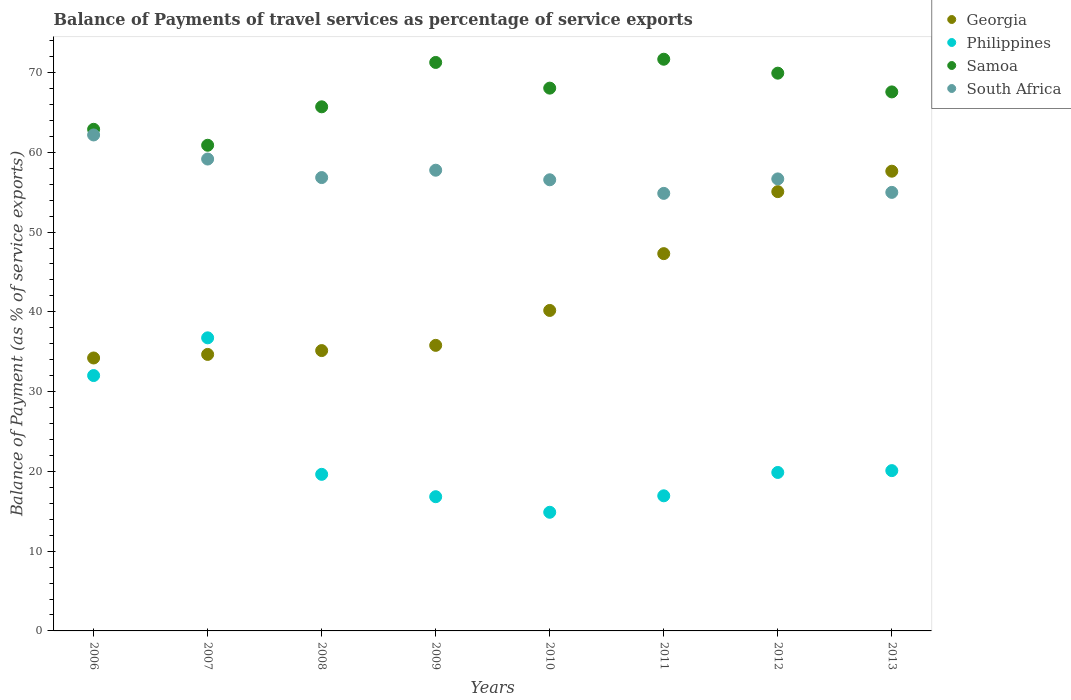How many different coloured dotlines are there?
Your answer should be compact. 4. Is the number of dotlines equal to the number of legend labels?
Make the answer very short. Yes. What is the balance of payments of travel services in Samoa in 2008?
Provide a succinct answer. 65.71. Across all years, what is the maximum balance of payments of travel services in South Africa?
Offer a terse response. 62.18. Across all years, what is the minimum balance of payments of travel services in Philippines?
Make the answer very short. 14.87. In which year was the balance of payments of travel services in Samoa maximum?
Keep it short and to the point. 2011. In which year was the balance of payments of travel services in Philippines minimum?
Make the answer very short. 2010. What is the total balance of payments of travel services in South Africa in the graph?
Your response must be concise. 458.98. What is the difference between the balance of payments of travel services in Samoa in 2006 and that in 2007?
Provide a succinct answer. 2. What is the difference between the balance of payments of travel services in Philippines in 2009 and the balance of payments of travel services in South Africa in 2012?
Offer a very short reply. -39.84. What is the average balance of payments of travel services in Philippines per year?
Ensure brevity in your answer.  22.12. In the year 2011, what is the difference between the balance of payments of travel services in Georgia and balance of payments of travel services in South Africa?
Offer a very short reply. -7.55. In how many years, is the balance of payments of travel services in Philippines greater than 12 %?
Provide a succinct answer. 8. What is the ratio of the balance of payments of travel services in South Africa in 2008 to that in 2010?
Your answer should be compact. 1. Is the difference between the balance of payments of travel services in Georgia in 2007 and 2011 greater than the difference between the balance of payments of travel services in South Africa in 2007 and 2011?
Your response must be concise. No. What is the difference between the highest and the second highest balance of payments of travel services in Georgia?
Your answer should be compact. 2.56. What is the difference between the highest and the lowest balance of payments of travel services in Samoa?
Your answer should be compact. 10.78. Is it the case that in every year, the sum of the balance of payments of travel services in Georgia and balance of payments of travel services in Samoa  is greater than the sum of balance of payments of travel services in Philippines and balance of payments of travel services in South Africa?
Offer a very short reply. No. Is the balance of payments of travel services in Philippines strictly greater than the balance of payments of travel services in Georgia over the years?
Make the answer very short. No. Where does the legend appear in the graph?
Ensure brevity in your answer.  Top right. How are the legend labels stacked?
Provide a short and direct response. Vertical. What is the title of the graph?
Your answer should be very brief. Balance of Payments of travel services as percentage of service exports. What is the label or title of the Y-axis?
Make the answer very short. Balance of Payment (as % of service exports). What is the Balance of Payment (as % of service exports) in Georgia in 2006?
Give a very brief answer. 34.22. What is the Balance of Payment (as % of service exports) of Philippines in 2006?
Offer a terse response. 32.02. What is the Balance of Payment (as % of service exports) of Samoa in 2006?
Provide a short and direct response. 62.88. What is the Balance of Payment (as % of service exports) of South Africa in 2006?
Offer a very short reply. 62.18. What is the Balance of Payment (as % of service exports) in Georgia in 2007?
Offer a very short reply. 34.66. What is the Balance of Payment (as % of service exports) of Philippines in 2007?
Your answer should be very brief. 36.74. What is the Balance of Payment (as % of service exports) of Samoa in 2007?
Offer a terse response. 60.89. What is the Balance of Payment (as % of service exports) of South Africa in 2007?
Your answer should be very brief. 59.16. What is the Balance of Payment (as % of service exports) in Georgia in 2008?
Provide a succinct answer. 35.15. What is the Balance of Payment (as % of service exports) in Philippines in 2008?
Provide a short and direct response. 19.63. What is the Balance of Payment (as % of service exports) of Samoa in 2008?
Ensure brevity in your answer.  65.71. What is the Balance of Payment (as % of service exports) of South Africa in 2008?
Your response must be concise. 56.83. What is the Balance of Payment (as % of service exports) of Georgia in 2009?
Ensure brevity in your answer.  35.8. What is the Balance of Payment (as % of service exports) of Philippines in 2009?
Provide a succinct answer. 16.83. What is the Balance of Payment (as % of service exports) of Samoa in 2009?
Make the answer very short. 71.27. What is the Balance of Payment (as % of service exports) of South Africa in 2009?
Make the answer very short. 57.76. What is the Balance of Payment (as % of service exports) in Georgia in 2010?
Your response must be concise. 40.18. What is the Balance of Payment (as % of service exports) of Philippines in 2010?
Give a very brief answer. 14.87. What is the Balance of Payment (as % of service exports) in Samoa in 2010?
Make the answer very short. 68.05. What is the Balance of Payment (as % of service exports) of South Africa in 2010?
Ensure brevity in your answer.  56.56. What is the Balance of Payment (as % of service exports) in Georgia in 2011?
Offer a terse response. 47.3. What is the Balance of Payment (as % of service exports) in Philippines in 2011?
Offer a very short reply. 16.94. What is the Balance of Payment (as % of service exports) of Samoa in 2011?
Provide a succinct answer. 71.67. What is the Balance of Payment (as % of service exports) of South Africa in 2011?
Provide a succinct answer. 54.85. What is the Balance of Payment (as % of service exports) of Georgia in 2012?
Your answer should be very brief. 55.07. What is the Balance of Payment (as % of service exports) in Philippines in 2012?
Your answer should be compact. 19.87. What is the Balance of Payment (as % of service exports) in Samoa in 2012?
Make the answer very short. 69.92. What is the Balance of Payment (as % of service exports) of South Africa in 2012?
Your response must be concise. 56.67. What is the Balance of Payment (as % of service exports) in Georgia in 2013?
Offer a very short reply. 57.63. What is the Balance of Payment (as % of service exports) of Philippines in 2013?
Provide a succinct answer. 20.1. What is the Balance of Payment (as % of service exports) in Samoa in 2013?
Make the answer very short. 67.57. What is the Balance of Payment (as % of service exports) of South Africa in 2013?
Provide a succinct answer. 54.98. Across all years, what is the maximum Balance of Payment (as % of service exports) of Georgia?
Your answer should be very brief. 57.63. Across all years, what is the maximum Balance of Payment (as % of service exports) of Philippines?
Keep it short and to the point. 36.74. Across all years, what is the maximum Balance of Payment (as % of service exports) in Samoa?
Provide a succinct answer. 71.67. Across all years, what is the maximum Balance of Payment (as % of service exports) of South Africa?
Your answer should be very brief. 62.18. Across all years, what is the minimum Balance of Payment (as % of service exports) in Georgia?
Ensure brevity in your answer.  34.22. Across all years, what is the minimum Balance of Payment (as % of service exports) in Philippines?
Offer a terse response. 14.87. Across all years, what is the minimum Balance of Payment (as % of service exports) of Samoa?
Keep it short and to the point. 60.89. Across all years, what is the minimum Balance of Payment (as % of service exports) of South Africa?
Offer a very short reply. 54.85. What is the total Balance of Payment (as % of service exports) of Georgia in the graph?
Offer a terse response. 340.01. What is the total Balance of Payment (as % of service exports) in Philippines in the graph?
Ensure brevity in your answer.  176.99. What is the total Balance of Payment (as % of service exports) in Samoa in the graph?
Provide a short and direct response. 537.96. What is the total Balance of Payment (as % of service exports) of South Africa in the graph?
Your answer should be very brief. 458.98. What is the difference between the Balance of Payment (as % of service exports) of Georgia in 2006 and that in 2007?
Provide a short and direct response. -0.45. What is the difference between the Balance of Payment (as % of service exports) in Philippines in 2006 and that in 2007?
Provide a short and direct response. -4.73. What is the difference between the Balance of Payment (as % of service exports) in Samoa in 2006 and that in 2007?
Provide a succinct answer. 2. What is the difference between the Balance of Payment (as % of service exports) of South Africa in 2006 and that in 2007?
Offer a very short reply. 3.02. What is the difference between the Balance of Payment (as % of service exports) of Georgia in 2006 and that in 2008?
Offer a very short reply. -0.93. What is the difference between the Balance of Payment (as % of service exports) in Philippines in 2006 and that in 2008?
Provide a succinct answer. 12.39. What is the difference between the Balance of Payment (as % of service exports) in Samoa in 2006 and that in 2008?
Your answer should be very brief. -2.82. What is the difference between the Balance of Payment (as % of service exports) of South Africa in 2006 and that in 2008?
Your response must be concise. 5.34. What is the difference between the Balance of Payment (as % of service exports) of Georgia in 2006 and that in 2009?
Offer a very short reply. -1.58. What is the difference between the Balance of Payment (as % of service exports) of Philippines in 2006 and that in 2009?
Your answer should be compact. 15.19. What is the difference between the Balance of Payment (as % of service exports) in Samoa in 2006 and that in 2009?
Provide a succinct answer. -8.38. What is the difference between the Balance of Payment (as % of service exports) in South Africa in 2006 and that in 2009?
Provide a short and direct response. 4.42. What is the difference between the Balance of Payment (as % of service exports) of Georgia in 2006 and that in 2010?
Keep it short and to the point. -5.96. What is the difference between the Balance of Payment (as % of service exports) of Philippines in 2006 and that in 2010?
Your answer should be compact. 17.14. What is the difference between the Balance of Payment (as % of service exports) of Samoa in 2006 and that in 2010?
Make the answer very short. -5.16. What is the difference between the Balance of Payment (as % of service exports) of South Africa in 2006 and that in 2010?
Make the answer very short. 5.62. What is the difference between the Balance of Payment (as % of service exports) in Georgia in 2006 and that in 2011?
Make the answer very short. -13.08. What is the difference between the Balance of Payment (as % of service exports) in Philippines in 2006 and that in 2011?
Your response must be concise. 15.08. What is the difference between the Balance of Payment (as % of service exports) in Samoa in 2006 and that in 2011?
Your answer should be compact. -8.79. What is the difference between the Balance of Payment (as % of service exports) of South Africa in 2006 and that in 2011?
Give a very brief answer. 7.32. What is the difference between the Balance of Payment (as % of service exports) in Georgia in 2006 and that in 2012?
Your response must be concise. -20.85. What is the difference between the Balance of Payment (as % of service exports) in Philippines in 2006 and that in 2012?
Your answer should be compact. 12.15. What is the difference between the Balance of Payment (as % of service exports) in Samoa in 2006 and that in 2012?
Keep it short and to the point. -7.04. What is the difference between the Balance of Payment (as % of service exports) of South Africa in 2006 and that in 2012?
Offer a very short reply. 5.51. What is the difference between the Balance of Payment (as % of service exports) in Georgia in 2006 and that in 2013?
Ensure brevity in your answer.  -23.42. What is the difference between the Balance of Payment (as % of service exports) in Philippines in 2006 and that in 2013?
Offer a very short reply. 11.92. What is the difference between the Balance of Payment (as % of service exports) of Samoa in 2006 and that in 2013?
Make the answer very short. -4.69. What is the difference between the Balance of Payment (as % of service exports) of South Africa in 2006 and that in 2013?
Your answer should be compact. 7.2. What is the difference between the Balance of Payment (as % of service exports) of Georgia in 2007 and that in 2008?
Your answer should be compact. -0.48. What is the difference between the Balance of Payment (as % of service exports) of Philippines in 2007 and that in 2008?
Your answer should be compact. 17.11. What is the difference between the Balance of Payment (as % of service exports) in Samoa in 2007 and that in 2008?
Offer a terse response. -4.82. What is the difference between the Balance of Payment (as % of service exports) in South Africa in 2007 and that in 2008?
Provide a succinct answer. 2.32. What is the difference between the Balance of Payment (as % of service exports) of Georgia in 2007 and that in 2009?
Offer a very short reply. -1.14. What is the difference between the Balance of Payment (as % of service exports) of Philippines in 2007 and that in 2009?
Provide a succinct answer. 19.92. What is the difference between the Balance of Payment (as % of service exports) of Samoa in 2007 and that in 2009?
Your response must be concise. -10.38. What is the difference between the Balance of Payment (as % of service exports) in South Africa in 2007 and that in 2009?
Ensure brevity in your answer.  1.4. What is the difference between the Balance of Payment (as % of service exports) of Georgia in 2007 and that in 2010?
Offer a very short reply. -5.51. What is the difference between the Balance of Payment (as % of service exports) of Philippines in 2007 and that in 2010?
Keep it short and to the point. 21.87. What is the difference between the Balance of Payment (as % of service exports) of Samoa in 2007 and that in 2010?
Give a very brief answer. -7.16. What is the difference between the Balance of Payment (as % of service exports) in South Africa in 2007 and that in 2010?
Your response must be concise. 2.6. What is the difference between the Balance of Payment (as % of service exports) of Georgia in 2007 and that in 2011?
Your answer should be compact. -12.63. What is the difference between the Balance of Payment (as % of service exports) of Philippines in 2007 and that in 2011?
Offer a terse response. 19.81. What is the difference between the Balance of Payment (as % of service exports) in Samoa in 2007 and that in 2011?
Your response must be concise. -10.79. What is the difference between the Balance of Payment (as % of service exports) in South Africa in 2007 and that in 2011?
Ensure brevity in your answer.  4.3. What is the difference between the Balance of Payment (as % of service exports) of Georgia in 2007 and that in 2012?
Offer a very short reply. -20.41. What is the difference between the Balance of Payment (as % of service exports) in Philippines in 2007 and that in 2012?
Keep it short and to the point. 16.88. What is the difference between the Balance of Payment (as % of service exports) in Samoa in 2007 and that in 2012?
Your answer should be compact. -9.04. What is the difference between the Balance of Payment (as % of service exports) of South Africa in 2007 and that in 2012?
Offer a terse response. 2.49. What is the difference between the Balance of Payment (as % of service exports) in Georgia in 2007 and that in 2013?
Give a very brief answer. -22.97. What is the difference between the Balance of Payment (as % of service exports) of Philippines in 2007 and that in 2013?
Offer a very short reply. 16.65. What is the difference between the Balance of Payment (as % of service exports) of Samoa in 2007 and that in 2013?
Offer a very short reply. -6.69. What is the difference between the Balance of Payment (as % of service exports) in South Africa in 2007 and that in 2013?
Offer a very short reply. 4.18. What is the difference between the Balance of Payment (as % of service exports) of Georgia in 2008 and that in 2009?
Your response must be concise. -0.65. What is the difference between the Balance of Payment (as % of service exports) in Philippines in 2008 and that in 2009?
Make the answer very short. 2.8. What is the difference between the Balance of Payment (as % of service exports) of Samoa in 2008 and that in 2009?
Make the answer very short. -5.56. What is the difference between the Balance of Payment (as % of service exports) of South Africa in 2008 and that in 2009?
Ensure brevity in your answer.  -0.92. What is the difference between the Balance of Payment (as % of service exports) of Georgia in 2008 and that in 2010?
Provide a succinct answer. -5.03. What is the difference between the Balance of Payment (as % of service exports) in Philippines in 2008 and that in 2010?
Provide a succinct answer. 4.75. What is the difference between the Balance of Payment (as % of service exports) of Samoa in 2008 and that in 2010?
Your answer should be compact. -2.34. What is the difference between the Balance of Payment (as % of service exports) in South Africa in 2008 and that in 2010?
Make the answer very short. 0.28. What is the difference between the Balance of Payment (as % of service exports) of Georgia in 2008 and that in 2011?
Offer a very short reply. -12.15. What is the difference between the Balance of Payment (as % of service exports) in Philippines in 2008 and that in 2011?
Make the answer very short. 2.69. What is the difference between the Balance of Payment (as % of service exports) in Samoa in 2008 and that in 2011?
Your response must be concise. -5.97. What is the difference between the Balance of Payment (as % of service exports) of South Africa in 2008 and that in 2011?
Ensure brevity in your answer.  1.98. What is the difference between the Balance of Payment (as % of service exports) in Georgia in 2008 and that in 2012?
Provide a short and direct response. -19.93. What is the difference between the Balance of Payment (as % of service exports) of Philippines in 2008 and that in 2012?
Ensure brevity in your answer.  -0.24. What is the difference between the Balance of Payment (as % of service exports) in Samoa in 2008 and that in 2012?
Your answer should be compact. -4.22. What is the difference between the Balance of Payment (as % of service exports) in South Africa in 2008 and that in 2012?
Provide a short and direct response. 0.17. What is the difference between the Balance of Payment (as % of service exports) in Georgia in 2008 and that in 2013?
Provide a succinct answer. -22.49. What is the difference between the Balance of Payment (as % of service exports) in Philippines in 2008 and that in 2013?
Your answer should be compact. -0.47. What is the difference between the Balance of Payment (as % of service exports) of Samoa in 2008 and that in 2013?
Keep it short and to the point. -1.87. What is the difference between the Balance of Payment (as % of service exports) in South Africa in 2008 and that in 2013?
Your response must be concise. 1.86. What is the difference between the Balance of Payment (as % of service exports) of Georgia in 2009 and that in 2010?
Your answer should be compact. -4.38. What is the difference between the Balance of Payment (as % of service exports) in Philippines in 2009 and that in 2010?
Keep it short and to the point. 1.95. What is the difference between the Balance of Payment (as % of service exports) of Samoa in 2009 and that in 2010?
Give a very brief answer. 3.22. What is the difference between the Balance of Payment (as % of service exports) of South Africa in 2009 and that in 2010?
Give a very brief answer. 1.2. What is the difference between the Balance of Payment (as % of service exports) of Georgia in 2009 and that in 2011?
Your response must be concise. -11.5. What is the difference between the Balance of Payment (as % of service exports) of Philippines in 2009 and that in 2011?
Ensure brevity in your answer.  -0.11. What is the difference between the Balance of Payment (as % of service exports) of Samoa in 2009 and that in 2011?
Provide a succinct answer. -0.4. What is the difference between the Balance of Payment (as % of service exports) of South Africa in 2009 and that in 2011?
Offer a very short reply. 2.9. What is the difference between the Balance of Payment (as % of service exports) in Georgia in 2009 and that in 2012?
Offer a very short reply. -19.27. What is the difference between the Balance of Payment (as % of service exports) in Philippines in 2009 and that in 2012?
Make the answer very short. -3.04. What is the difference between the Balance of Payment (as % of service exports) of Samoa in 2009 and that in 2012?
Your answer should be very brief. 1.34. What is the difference between the Balance of Payment (as % of service exports) of South Africa in 2009 and that in 2012?
Provide a short and direct response. 1.09. What is the difference between the Balance of Payment (as % of service exports) in Georgia in 2009 and that in 2013?
Provide a succinct answer. -21.83. What is the difference between the Balance of Payment (as % of service exports) in Philippines in 2009 and that in 2013?
Provide a short and direct response. -3.27. What is the difference between the Balance of Payment (as % of service exports) in Samoa in 2009 and that in 2013?
Your response must be concise. 3.69. What is the difference between the Balance of Payment (as % of service exports) of South Africa in 2009 and that in 2013?
Offer a very short reply. 2.78. What is the difference between the Balance of Payment (as % of service exports) of Georgia in 2010 and that in 2011?
Provide a succinct answer. -7.12. What is the difference between the Balance of Payment (as % of service exports) in Philippines in 2010 and that in 2011?
Provide a short and direct response. -2.06. What is the difference between the Balance of Payment (as % of service exports) in Samoa in 2010 and that in 2011?
Your answer should be compact. -3.62. What is the difference between the Balance of Payment (as % of service exports) of South Africa in 2010 and that in 2011?
Give a very brief answer. 1.7. What is the difference between the Balance of Payment (as % of service exports) of Georgia in 2010 and that in 2012?
Your answer should be compact. -14.89. What is the difference between the Balance of Payment (as % of service exports) of Philippines in 2010 and that in 2012?
Offer a very short reply. -4.99. What is the difference between the Balance of Payment (as % of service exports) of Samoa in 2010 and that in 2012?
Your answer should be compact. -1.88. What is the difference between the Balance of Payment (as % of service exports) in South Africa in 2010 and that in 2012?
Provide a succinct answer. -0.11. What is the difference between the Balance of Payment (as % of service exports) of Georgia in 2010 and that in 2013?
Your response must be concise. -17.46. What is the difference between the Balance of Payment (as % of service exports) of Philippines in 2010 and that in 2013?
Give a very brief answer. -5.22. What is the difference between the Balance of Payment (as % of service exports) in Samoa in 2010 and that in 2013?
Make the answer very short. 0.47. What is the difference between the Balance of Payment (as % of service exports) of South Africa in 2010 and that in 2013?
Provide a short and direct response. 1.58. What is the difference between the Balance of Payment (as % of service exports) in Georgia in 2011 and that in 2012?
Keep it short and to the point. -7.77. What is the difference between the Balance of Payment (as % of service exports) in Philippines in 2011 and that in 2012?
Give a very brief answer. -2.93. What is the difference between the Balance of Payment (as % of service exports) of Samoa in 2011 and that in 2012?
Offer a terse response. 1.75. What is the difference between the Balance of Payment (as % of service exports) in South Africa in 2011 and that in 2012?
Provide a short and direct response. -1.81. What is the difference between the Balance of Payment (as % of service exports) in Georgia in 2011 and that in 2013?
Provide a short and direct response. -10.34. What is the difference between the Balance of Payment (as % of service exports) of Philippines in 2011 and that in 2013?
Your response must be concise. -3.16. What is the difference between the Balance of Payment (as % of service exports) of Samoa in 2011 and that in 2013?
Provide a short and direct response. 4.1. What is the difference between the Balance of Payment (as % of service exports) of South Africa in 2011 and that in 2013?
Your answer should be compact. -0.12. What is the difference between the Balance of Payment (as % of service exports) in Georgia in 2012 and that in 2013?
Offer a very short reply. -2.56. What is the difference between the Balance of Payment (as % of service exports) of Philippines in 2012 and that in 2013?
Your answer should be compact. -0.23. What is the difference between the Balance of Payment (as % of service exports) of Samoa in 2012 and that in 2013?
Ensure brevity in your answer.  2.35. What is the difference between the Balance of Payment (as % of service exports) in South Africa in 2012 and that in 2013?
Offer a very short reply. 1.69. What is the difference between the Balance of Payment (as % of service exports) in Georgia in 2006 and the Balance of Payment (as % of service exports) in Philippines in 2007?
Your answer should be compact. -2.53. What is the difference between the Balance of Payment (as % of service exports) of Georgia in 2006 and the Balance of Payment (as % of service exports) of Samoa in 2007?
Your answer should be very brief. -26.67. What is the difference between the Balance of Payment (as % of service exports) of Georgia in 2006 and the Balance of Payment (as % of service exports) of South Africa in 2007?
Offer a terse response. -24.94. What is the difference between the Balance of Payment (as % of service exports) of Philippines in 2006 and the Balance of Payment (as % of service exports) of Samoa in 2007?
Ensure brevity in your answer.  -28.87. What is the difference between the Balance of Payment (as % of service exports) of Philippines in 2006 and the Balance of Payment (as % of service exports) of South Africa in 2007?
Offer a very short reply. -27.14. What is the difference between the Balance of Payment (as % of service exports) in Samoa in 2006 and the Balance of Payment (as % of service exports) in South Africa in 2007?
Provide a succinct answer. 3.73. What is the difference between the Balance of Payment (as % of service exports) of Georgia in 2006 and the Balance of Payment (as % of service exports) of Philippines in 2008?
Keep it short and to the point. 14.59. What is the difference between the Balance of Payment (as % of service exports) in Georgia in 2006 and the Balance of Payment (as % of service exports) in Samoa in 2008?
Make the answer very short. -31.49. What is the difference between the Balance of Payment (as % of service exports) in Georgia in 2006 and the Balance of Payment (as % of service exports) in South Africa in 2008?
Your answer should be very brief. -22.62. What is the difference between the Balance of Payment (as % of service exports) of Philippines in 2006 and the Balance of Payment (as % of service exports) of Samoa in 2008?
Your response must be concise. -33.69. What is the difference between the Balance of Payment (as % of service exports) in Philippines in 2006 and the Balance of Payment (as % of service exports) in South Africa in 2008?
Give a very brief answer. -24.82. What is the difference between the Balance of Payment (as % of service exports) of Samoa in 2006 and the Balance of Payment (as % of service exports) of South Africa in 2008?
Give a very brief answer. 6.05. What is the difference between the Balance of Payment (as % of service exports) of Georgia in 2006 and the Balance of Payment (as % of service exports) of Philippines in 2009?
Keep it short and to the point. 17.39. What is the difference between the Balance of Payment (as % of service exports) in Georgia in 2006 and the Balance of Payment (as % of service exports) in Samoa in 2009?
Give a very brief answer. -37.05. What is the difference between the Balance of Payment (as % of service exports) in Georgia in 2006 and the Balance of Payment (as % of service exports) in South Africa in 2009?
Keep it short and to the point. -23.54. What is the difference between the Balance of Payment (as % of service exports) in Philippines in 2006 and the Balance of Payment (as % of service exports) in Samoa in 2009?
Keep it short and to the point. -39.25. What is the difference between the Balance of Payment (as % of service exports) in Philippines in 2006 and the Balance of Payment (as % of service exports) in South Africa in 2009?
Your answer should be very brief. -25.74. What is the difference between the Balance of Payment (as % of service exports) in Samoa in 2006 and the Balance of Payment (as % of service exports) in South Africa in 2009?
Your answer should be very brief. 5.13. What is the difference between the Balance of Payment (as % of service exports) in Georgia in 2006 and the Balance of Payment (as % of service exports) in Philippines in 2010?
Keep it short and to the point. 19.34. What is the difference between the Balance of Payment (as % of service exports) in Georgia in 2006 and the Balance of Payment (as % of service exports) in Samoa in 2010?
Offer a terse response. -33.83. What is the difference between the Balance of Payment (as % of service exports) in Georgia in 2006 and the Balance of Payment (as % of service exports) in South Africa in 2010?
Give a very brief answer. -22.34. What is the difference between the Balance of Payment (as % of service exports) of Philippines in 2006 and the Balance of Payment (as % of service exports) of Samoa in 2010?
Give a very brief answer. -36.03. What is the difference between the Balance of Payment (as % of service exports) in Philippines in 2006 and the Balance of Payment (as % of service exports) in South Africa in 2010?
Provide a short and direct response. -24.54. What is the difference between the Balance of Payment (as % of service exports) of Samoa in 2006 and the Balance of Payment (as % of service exports) of South Africa in 2010?
Keep it short and to the point. 6.33. What is the difference between the Balance of Payment (as % of service exports) in Georgia in 2006 and the Balance of Payment (as % of service exports) in Philippines in 2011?
Make the answer very short. 17.28. What is the difference between the Balance of Payment (as % of service exports) in Georgia in 2006 and the Balance of Payment (as % of service exports) in Samoa in 2011?
Offer a very short reply. -37.45. What is the difference between the Balance of Payment (as % of service exports) of Georgia in 2006 and the Balance of Payment (as % of service exports) of South Africa in 2011?
Provide a succinct answer. -20.64. What is the difference between the Balance of Payment (as % of service exports) of Philippines in 2006 and the Balance of Payment (as % of service exports) of Samoa in 2011?
Keep it short and to the point. -39.66. What is the difference between the Balance of Payment (as % of service exports) of Philippines in 2006 and the Balance of Payment (as % of service exports) of South Africa in 2011?
Ensure brevity in your answer.  -22.84. What is the difference between the Balance of Payment (as % of service exports) of Samoa in 2006 and the Balance of Payment (as % of service exports) of South Africa in 2011?
Your response must be concise. 8.03. What is the difference between the Balance of Payment (as % of service exports) of Georgia in 2006 and the Balance of Payment (as % of service exports) of Philippines in 2012?
Your answer should be very brief. 14.35. What is the difference between the Balance of Payment (as % of service exports) in Georgia in 2006 and the Balance of Payment (as % of service exports) in Samoa in 2012?
Keep it short and to the point. -35.71. What is the difference between the Balance of Payment (as % of service exports) of Georgia in 2006 and the Balance of Payment (as % of service exports) of South Africa in 2012?
Ensure brevity in your answer.  -22.45. What is the difference between the Balance of Payment (as % of service exports) of Philippines in 2006 and the Balance of Payment (as % of service exports) of Samoa in 2012?
Give a very brief answer. -37.91. What is the difference between the Balance of Payment (as % of service exports) of Philippines in 2006 and the Balance of Payment (as % of service exports) of South Africa in 2012?
Your answer should be very brief. -24.65. What is the difference between the Balance of Payment (as % of service exports) of Samoa in 2006 and the Balance of Payment (as % of service exports) of South Africa in 2012?
Make the answer very short. 6.22. What is the difference between the Balance of Payment (as % of service exports) in Georgia in 2006 and the Balance of Payment (as % of service exports) in Philippines in 2013?
Provide a short and direct response. 14.12. What is the difference between the Balance of Payment (as % of service exports) of Georgia in 2006 and the Balance of Payment (as % of service exports) of Samoa in 2013?
Make the answer very short. -33.36. What is the difference between the Balance of Payment (as % of service exports) in Georgia in 2006 and the Balance of Payment (as % of service exports) in South Africa in 2013?
Your answer should be compact. -20.76. What is the difference between the Balance of Payment (as % of service exports) in Philippines in 2006 and the Balance of Payment (as % of service exports) in Samoa in 2013?
Make the answer very short. -35.56. What is the difference between the Balance of Payment (as % of service exports) in Philippines in 2006 and the Balance of Payment (as % of service exports) in South Africa in 2013?
Provide a succinct answer. -22.96. What is the difference between the Balance of Payment (as % of service exports) in Samoa in 2006 and the Balance of Payment (as % of service exports) in South Africa in 2013?
Provide a short and direct response. 7.91. What is the difference between the Balance of Payment (as % of service exports) of Georgia in 2007 and the Balance of Payment (as % of service exports) of Philippines in 2008?
Provide a short and direct response. 15.03. What is the difference between the Balance of Payment (as % of service exports) in Georgia in 2007 and the Balance of Payment (as % of service exports) in Samoa in 2008?
Your answer should be compact. -31.04. What is the difference between the Balance of Payment (as % of service exports) of Georgia in 2007 and the Balance of Payment (as % of service exports) of South Africa in 2008?
Ensure brevity in your answer.  -22.17. What is the difference between the Balance of Payment (as % of service exports) in Philippines in 2007 and the Balance of Payment (as % of service exports) in Samoa in 2008?
Give a very brief answer. -28.96. What is the difference between the Balance of Payment (as % of service exports) of Philippines in 2007 and the Balance of Payment (as % of service exports) of South Africa in 2008?
Keep it short and to the point. -20.09. What is the difference between the Balance of Payment (as % of service exports) in Samoa in 2007 and the Balance of Payment (as % of service exports) in South Africa in 2008?
Provide a succinct answer. 4.05. What is the difference between the Balance of Payment (as % of service exports) in Georgia in 2007 and the Balance of Payment (as % of service exports) in Philippines in 2009?
Your response must be concise. 17.84. What is the difference between the Balance of Payment (as % of service exports) of Georgia in 2007 and the Balance of Payment (as % of service exports) of Samoa in 2009?
Your answer should be very brief. -36.6. What is the difference between the Balance of Payment (as % of service exports) in Georgia in 2007 and the Balance of Payment (as % of service exports) in South Africa in 2009?
Your response must be concise. -23.09. What is the difference between the Balance of Payment (as % of service exports) in Philippines in 2007 and the Balance of Payment (as % of service exports) in Samoa in 2009?
Your answer should be very brief. -34.52. What is the difference between the Balance of Payment (as % of service exports) in Philippines in 2007 and the Balance of Payment (as % of service exports) in South Africa in 2009?
Keep it short and to the point. -21.01. What is the difference between the Balance of Payment (as % of service exports) of Samoa in 2007 and the Balance of Payment (as % of service exports) of South Africa in 2009?
Your answer should be very brief. 3.13. What is the difference between the Balance of Payment (as % of service exports) in Georgia in 2007 and the Balance of Payment (as % of service exports) in Philippines in 2010?
Offer a terse response. 19.79. What is the difference between the Balance of Payment (as % of service exports) in Georgia in 2007 and the Balance of Payment (as % of service exports) in Samoa in 2010?
Offer a very short reply. -33.38. What is the difference between the Balance of Payment (as % of service exports) of Georgia in 2007 and the Balance of Payment (as % of service exports) of South Africa in 2010?
Your response must be concise. -21.89. What is the difference between the Balance of Payment (as % of service exports) in Philippines in 2007 and the Balance of Payment (as % of service exports) in Samoa in 2010?
Give a very brief answer. -31.3. What is the difference between the Balance of Payment (as % of service exports) of Philippines in 2007 and the Balance of Payment (as % of service exports) of South Africa in 2010?
Give a very brief answer. -19.81. What is the difference between the Balance of Payment (as % of service exports) of Samoa in 2007 and the Balance of Payment (as % of service exports) of South Africa in 2010?
Provide a succinct answer. 4.33. What is the difference between the Balance of Payment (as % of service exports) of Georgia in 2007 and the Balance of Payment (as % of service exports) of Philippines in 2011?
Offer a very short reply. 17.73. What is the difference between the Balance of Payment (as % of service exports) in Georgia in 2007 and the Balance of Payment (as % of service exports) in Samoa in 2011?
Your answer should be compact. -37.01. What is the difference between the Balance of Payment (as % of service exports) of Georgia in 2007 and the Balance of Payment (as % of service exports) of South Africa in 2011?
Provide a succinct answer. -20.19. What is the difference between the Balance of Payment (as % of service exports) in Philippines in 2007 and the Balance of Payment (as % of service exports) in Samoa in 2011?
Provide a succinct answer. -34.93. What is the difference between the Balance of Payment (as % of service exports) in Philippines in 2007 and the Balance of Payment (as % of service exports) in South Africa in 2011?
Offer a very short reply. -18.11. What is the difference between the Balance of Payment (as % of service exports) of Samoa in 2007 and the Balance of Payment (as % of service exports) of South Africa in 2011?
Keep it short and to the point. 6.03. What is the difference between the Balance of Payment (as % of service exports) in Georgia in 2007 and the Balance of Payment (as % of service exports) in Philippines in 2012?
Provide a succinct answer. 14.8. What is the difference between the Balance of Payment (as % of service exports) in Georgia in 2007 and the Balance of Payment (as % of service exports) in Samoa in 2012?
Keep it short and to the point. -35.26. What is the difference between the Balance of Payment (as % of service exports) in Georgia in 2007 and the Balance of Payment (as % of service exports) in South Africa in 2012?
Your response must be concise. -22. What is the difference between the Balance of Payment (as % of service exports) of Philippines in 2007 and the Balance of Payment (as % of service exports) of Samoa in 2012?
Keep it short and to the point. -33.18. What is the difference between the Balance of Payment (as % of service exports) of Philippines in 2007 and the Balance of Payment (as % of service exports) of South Africa in 2012?
Give a very brief answer. -19.92. What is the difference between the Balance of Payment (as % of service exports) of Samoa in 2007 and the Balance of Payment (as % of service exports) of South Africa in 2012?
Offer a terse response. 4.22. What is the difference between the Balance of Payment (as % of service exports) of Georgia in 2007 and the Balance of Payment (as % of service exports) of Philippines in 2013?
Provide a succinct answer. 14.57. What is the difference between the Balance of Payment (as % of service exports) in Georgia in 2007 and the Balance of Payment (as % of service exports) in Samoa in 2013?
Make the answer very short. -32.91. What is the difference between the Balance of Payment (as % of service exports) in Georgia in 2007 and the Balance of Payment (as % of service exports) in South Africa in 2013?
Provide a succinct answer. -20.31. What is the difference between the Balance of Payment (as % of service exports) of Philippines in 2007 and the Balance of Payment (as % of service exports) of Samoa in 2013?
Make the answer very short. -30.83. What is the difference between the Balance of Payment (as % of service exports) of Philippines in 2007 and the Balance of Payment (as % of service exports) of South Africa in 2013?
Make the answer very short. -18.23. What is the difference between the Balance of Payment (as % of service exports) of Samoa in 2007 and the Balance of Payment (as % of service exports) of South Africa in 2013?
Your answer should be compact. 5.91. What is the difference between the Balance of Payment (as % of service exports) of Georgia in 2008 and the Balance of Payment (as % of service exports) of Philippines in 2009?
Your answer should be compact. 18.32. What is the difference between the Balance of Payment (as % of service exports) of Georgia in 2008 and the Balance of Payment (as % of service exports) of Samoa in 2009?
Provide a succinct answer. -36.12. What is the difference between the Balance of Payment (as % of service exports) of Georgia in 2008 and the Balance of Payment (as % of service exports) of South Africa in 2009?
Keep it short and to the point. -22.61. What is the difference between the Balance of Payment (as % of service exports) of Philippines in 2008 and the Balance of Payment (as % of service exports) of Samoa in 2009?
Keep it short and to the point. -51.64. What is the difference between the Balance of Payment (as % of service exports) of Philippines in 2008 and the Balance of Payment (as % of service exports) of South Africa in 2009?
Provide a succinct answer. -38.13. What is the difference between the Balance of Payment (as % of service exports) of Samoa in 2008 and the Balance of Payment (as % of service exports) of South Africa in 2009?
Provide a succinct answer. 7.95. What is the difference between the Balance of Payment (as % of service exports) of Georgia in 2008 and the Balance of Payment (as % of service exports) of Philippines in 2010?
Offer a very short reply. 20.27. What is the difference between the Balance of Payment (as % of service exports) of Georgia in 2008 and the Balance of Payment (as % of service exports) of Samoa in 2010?
Offer a terse response. -32.9. What is the difference between the Balance of Payment (as % of service exports) in Georgia in 2008 and the Balance of Payment (as % of service exports) in South Africa in 2010?
Your response must be concise. -21.41. What is the difference between the Balance of Payment (as % of service exports) in Philippines in 2008 and the Balance of Payment (as % of service exports) in Samoa in 2010?
Your answer should be compact. -48.42. What is the difference between the Balance of Payment (as % of service exports) in Philippines in 2008 and the Balance of Payment (as % of service exports) in South Africa in 2010?
Your answer should be very brief. -36.93. What is the difference between the Balance of Payment (as % of service exports) of Samoa in 2008 and the Balance of Payment (as % of service exports) of South Africa in 2010?
Your answer should be very brief. 9.15. What is the difference between the Balance of Payment (as % of service exports) in Georgia in 2008 and the Balance of Payment (as % of service exports) in Philippines in 2011?
Make the answer very short. 18.21. What is the difference between the Balance of Payment (as % of service exports) of Georgia in 2008 and the Balance of Payment (as % of service exports) of Samoa in 2011?
Keep it short and to the point. -36.53. What is the difference between the Balance of Payment (as % of service exports) in Georgia in 2008 and the Balance of Payment (as % of service exports) in South Africa in 2011?
Keep it short and to the point. -19.71. What is the difference between the Balance of Payment (as % of service exports) in Philippines in 2008 and the Balance of Payment (as % of service exports) in Samoa in 2011?
Make the answer very short. -52.04. What is the difference between the Balance of Payment (as % of service exports) of Philippines in 2008 and the Balance of Payment (as % of service exports) of South Africa in 2011?
Your response must be concise. -35.22. What is the difference between the Balance of Payment (as % of service exports) in Samoa in 2008 and the Balance of Payment (as % of service exports) in South Africa in 2011?
Provide a succinct answer. 10.85. What is the difference between the Balance of Payment (as % of service exports) in Georgia in 2008 and the Balance of Payment (as % of service exports) in Philippines in 2012?
Your answer should be compact. 15.28. What is the difference between the Balance of Payment (as % of service exports) in Georgia in 2008 and the Balance of Payment (as % of service exports) in Samoa in 2012?
Your answer should be compact. -34.78. What is the difference between the Balance of Payment (as % of service exports) of Georgia in 2008 and the Balance of Payment (as % of service exports) of South Africa in 2012?
Your answer should be compact. -21.52. What is the difference between the Balance of Payment (as % of service exports) of Philippines in 2008 and the Balance of Payment (as % of service exports) of Samoa in 2012?
Make the answer very short. -50.29. What is the difference between the Balance of Payment (as % of service exports) in Philippines in 2008 and the Balance of Payment (as % of service exports) in South Africa in 2012?
Keep it short and to the point. -37.04. What is the difference between the Balance of Payment (as % of service exports) in Samoa in 2008 and the Balance of Payment (as % of service exports) in South Africa in 2012?
Offer a terse response. 9.04. What is the difference between the Balance of Payment (as % of service exports) in Georgia in 2008 and the Balance of Payment (as % of service exports) in Philippines in 2013?
Provide a short and direct response. 15.05. What is the difference between the Balance of Payment (as % of service exports) in Georgia in 2008 and the Balance of Payment (as % of service exports) in Samoa in 2013?
Your answer should be very brief. -32.43. What is the difference between the Balance of Payment (as % of service exports) in Georgia in 2008 and the Balance of Payment (as % of service exports) in South Africa in 2013?
Your response must be concise. -19.83. What is the difference between the Balance of Payment (as % of service exports) of Philippines in 2008 and the Balance of Payment (as % of service exports) of Samoa in 2013?
Ensure brevity in your answer.  -47.94. What is the difference between the Balance of Payment (as % of service exports) of Philippines in 2008 and the Balance of Payment (as % of service exports) of South Africa in 2013?
Provide a short and direct response. -35.35. What is the difference between the Balance of Payment (as % of service exports) of Samoa in 2008 and the Balance of Payment (as % of service exports) of South Africa in 2013?
Your answer should be very brief. 10.73. What is the difference between the Balance of Payment (as % of service exports) in Georgia in 2009 and the Balance of Payment (as % of service exports) in Philippines in 2010?
Provide a succinct answer. 20.92. What is the difference between the Balance of Payment (as % of service exports) of Georgia in 2009 and the Balance of Payment (as % of service exports) of Samoa in 2010?
Your answer should be compact. -32.25. What is the difference between the Balance of Payment (as % of service exports) in Georgia in 2009 and the Balance of Payment (as % of service exports) in South Africa in 2010?
Offer a terse response. -20.76. What is the difference between the Balance of Payment (as % of service exports) of Philippines in 2009 and the Balance of Payment (as % of service exports) of Samoa in 2010?
Offer a very short reply. -51.22. What is the difference between the Balance of Payment (as % of service exports) of Philippines in 2009 and the Balance of Payment (as % of service exports) of South Africa in 2010?
Ensure brevity in your answer.  -39.73. What is the difference between the Balance of Payment (as % of service exports) in Samoa in 2009 and the Balance of Payment (as % of service exports) in South Africa in 2010?
Keep it short and to the point. 14.71. What is the difference between the Balance of Payment (as % of service exports) in Georgia in 2009 and the Balance of Payment (as % of service exports) in Philippines in 2011?
Your response must be concise. 18.86. What is the difference between the Balance of Payment (as % of service exports) in Georgia in 2009 and the Balance of Payment (as % of service exports) in Samoa in 2011?
Your answer should be compact. -35.87. What is the difference between the Balance of Payment (as % of service exports) of Georgia in 2009 and the Balance of Payment (as % of service exports) of South Africa in 2011?
Your response must be concise. -19.05. What is the difference between the Balance of Payment (as % of service exports) of Philippines in 2009 and the Balance of Payment (as % of service exports) of Samoa in 2011?
Your response must be concise. -54.84. What is the difference between the Balance of Payment (as % of service exports) of Philippines in 2009 and the Balance of Payment (as % of service exports) of South Africa in 2011?
Offer a very short reply. -38.03. What is the difference between the Balance of Payment (as % of service exports) of Samoa in 2009 and the Balance of Payment (as % of service exports) of South Africa in 2011?
Offer a very short reply. 16.42. What is the difference between the Balance of Payment (as % of service exports) of Georgia in 2009 and the Balance of Payment (as % of service exports) of Philippines in 2012?
Give a very brief answer. 15.93. What is the difference between the Balance of Payment (as % of service exports) of Georgia in 2009 and the Balance of Payment (as % of service exports) of Samoa in 2012?
Provide a short and direct response. -34.12. What is the difference between the Balance of Payment (as % of service exports) in Georgia in 2009 and the Balance of Payment (as % of service exports) in South Africa in 2012?
Provide a succinct answer. -20.87. What is the difference between the Balance of Payment (as % of service exports) of Philippines in 2009 and the Balance of Payment (as % of service exports) of Samoa in 2012?
Your answer should be very brief. -53.1. What is the difference between the Balance of Payment (as % of service exports) in Philippines in 2009 and the Balance of Payment (as % of service exports) in South Africa in 2012?
Provide a short and direct response. -39.84. What is the difference between the Balance of Payment (as % of service exports) of Samoa in 2009 and the Balance of Payment (as % of service exports) of South Africa in 2012?
Provide a short and direct response. 14.6. What is the difference between the Balance of Payment (as % of service exports) in Georgia in 2009 and the Balance of Payment (as % of service exports) in Philippines in 2013?
Offer a very short reply. 15.7. What is the difference between the Balance of Payment (as % of service exports) of Georgia in 2009 and the Balance of Payment (as % of service exports) of Samoa in 2013?
Give a very brief answer. -31.77. What is the difference between the Balance of Payment (as % of service exports) of Georgia in 2009 and the Balance of Payment (as % of service exports) of South Africa in 2013?
Your answer should be compact. -19.18. What is the difference between the Balance of Payment (as % of service exports) of Philippines in 2009 and the Balance of Payment (as % of service exports) of Samoa in 2013?
Offer a terse response. -50.75. What is the difference between the Balance of Payment (as % of service exports) in Philippines in 2009 and the Balance of Payment (as % of service exports) in South Africa in 2013?
Your response must be concise. -38.15. What is the difference between the Balance of Payment (as % of service exports) in Samoa in 2009 and the Balance of Payment (as % of service exports) in South Africa in 2013?
Make the answer very short. 16.29. What is the difference between the Balance of Payment (as % of service exports) of Georgia in 2010 and the Balance of Payment (as % of service exports) of Philippines in 2011?
Provide a succinct answer. 23.24. What is the difference between the Balance of Payment (as % of service exports) of Georgia in 2010 and the Balance of Payment (as % of service exports) of Samoa in 2011?
Your response must be concise. -31.49. What is the difference between the Balance of Payment (as % of service exports) of Georgia in 2010 and the Balance of Payment (as % of service exports) of South Africa in 2011?
Offer a terse response. -14.68. What is the difference between the Balance of Payment (as % of service exports) in Philippines in 2010 and the Balance of Payment (as % of service exports) in Samoa in 2011?
Make the answer very short. -56.8. What is the difference between the Balance of Payment (as % of service exports) in Philippines in 2010 and the Balance of Payment (as % of service exports) in South Africa in 2011?
Your answer should be very brief. -39.98. What is the difference between the Balance of Payment (as % of service exports) in Samoa in 2010 and the Balance of Payment (as % of service exports) in South Africa in 2011?
Provide a succinct answer. 13.19. What is the difference between the Balance of Payment (as % of service exports) of Georgia in 2010 and the Balance of Payment (as % of service exports) of Philippines in 2012?
Your response must be concise. 20.31. What is the difference between the Balance of Payment (as % of service exports) in Georgia in 2010 and the Balance of Payment (as % of service exports) in Samoa in 2012?
Ensure brevity in your answer.  -29.75. What is the difference between the Balance of Payment (as % of service exports) of Georgia in 2010 and the Balance of Payment (as % of service exports) of South Africa in 2012?
Keep it short and to the point. -16.49. What is the difference between the Balance of Payment (as % of service exports) in Philippines in 2010 and the Balance of Payment (as % of service exports) in Samoa in 2012?
Your answer should be very brief. -55.05. What is the difference between the Balance of Payment (as % of service exports) of Philippines in 2010 and the Balance of Payment (as % of service exports) of South Africa in 2012?
Keep it short and to the point. -41.79. What is the difference between the Balance of Payment (as % of service exports) of Samoa in 2010 and the Balance of Payment (as % of service exports) of South Africa in 2012?
Keep it short and to the point. 11.38. What is the difference between the Balance of Payment (as % of service exports) of Georgia in 2010 and the Balance of Payment (as % of service exports) of Philippines in 2013?
Your answer should be compact. 20.08. What is the difference between the Balance of Payment (as % of service exports) in Georgia in 2010 and the Balance of Payment (as % of service exports) in Samoa in 2013?
Offer a terse response. -27.4. What is the difference between the Balance of Payment (as % of service exports) in Georgia in 2010 and the Balance of Payment (as % of service exports) in South Africa in 2013?
Your answer should be very brief. -14.8. What is the difference between the Balance of Payment (as % of service exports) in Philippines in 2010 and the Balance of Payment (as % of service exports) in Samoa in 2013?
Give a very brief answer. -52.7. What is the difference between the Balance of Payment (as % of service exports) in Philippines in 2010 and the Balance of Payment (as % of service exports) in South Africa in 2013?
Provide a succinct answer. -40.1. What is the difference between the Balance of Payment (as % of service exports) of Samoa in 2010 and the Balance of Payment (as % of service exports) of South Africa in 2013?
Your response must be concise. 13.07. What is the difference between the Balance of Payment (as % of service exports) of Georgia in 2011 and the Balance of Payment (as % of service exports) of Philippines in 2012?
Your response must be concise. 27.43. What is the difference between the Balance of Payment (as % of service exports) in Georgia in 2011 and the Balance of Payment (as % of service exports) in Samoa in 2012?
Provide a succinct answer. -22.63. What is the difference between the Balance of Payment (as % of service exports) of Georgia in 2011 and the Balance of Payment (as % of service exports) of South Africa in 2012?
Offer a terse response. -9.37. What is the difference between the Balance of Payment (as % of service exports) of Philippines in 2011 and the Balance of Payment (as % of service exports) of Samoa in 2012?
Give a very brief answer. -52.99. What is the difference between the Balance of Payment (as % of service exports) in Philippines in 2011 and the Balance of Payment (as % of service exports) in South Africa in 2012?
Give a very brief answer. -39.73. What is the difference between the Balance of Payment (as % of service exports) of Samoa in 2011 and the Balance of Payment (as % of service exports) of South Africa in 2012?
Offer a terse response. 15. What is the difference between the Balance of Payment (as % of service exports) of Georgia in 2011 and the Balance of Payment (as % of service exports) of Philippines in 2013?
Keep it short and to the point. 27.2. What is the difference between the Balance of Payment (as % of service exports) of Georgia in 2011 and the Balance of Payment (as % of service exports) of Samoa in 2013?
Ensure brevity in your answer.  -20.28. What is the difference between the Balance of Payment (as % of service exports) of Georgia in 2011 and the Balance of Payment (as % of service exports) of South Africa in 2013?
Give a very brief answer. -7.68. What is the difference between the Balance of Payment (as % of service exports) in Philippines in 2011 and the Balance of Payment (as % of service exports) in Samoa in 2013?
Keep it short and to the point. -50.64. What is the difference between the Balance of Payment (as % of service exports) in Philippines in 2011 and the Balance of Payment (as % of service exports) in South Africa in 2013?
Your response must be concise. -38.04. What is the difference between the Balance of Payment (as % of service exports) in Samoa in 2011 and the Balance of Payment (as % of service exports) in South Africa in 2013?
Provide a short and direct response. 16.69. What is the difference between the Balance of Payment (as % of service exports) in Georgia in 2012 and the Balance of Payment (as % of service exports) in Philippines in 2013?
Give a very brief answer. 34.97. What is the difference between the Balance of Payment (as % of service exports) of Georgia in 2012 and the Balance of Payment (as % of service exports) of Samoa in 2013?
Offer a terse response. -12.5. What is the difference between the Balance of Payment (as % of service exports) in Georgia in 2012 and the Balance of Payment (as % of service exports) in South Africa in 2013?
Provide a short and direct response. 0.09. What is the difference between the Balance of Payment (as % of service exports) of Philippines in 2012 and the Balance of Payment (as % of service exports) of Samoa in 2013?
Make the answer very short. -47.71. What is the difference between the Balance of Payment (as % of service exports) of Philippines in 2012 and the Balance of Payment (as % of service exports) of South Africa in 2013?
Provide a short and direct response. -35.11. What is the difference between the Balance of Payment (as % of service exports) in Samoa in 2012 and the Balance of Payment (as % of service exports) in South Africa in 2013?
Ensure brevity in your answer.  14.95. What is the average Balance of Payment (as % of service exports) in Georgia per year?
Provide a short and direct response. 42.5. What is the average Balance of Payment (as % of service exports) of Philippines per year?
Provide a succinct answer. 22.12. What is the average Balance of Payment (as % of service exports) in Samoa per year?
Your response must be concise. 67.24. What is the average Balance of Payment (as % of service exports) of South Africa per year?
Offer a very short reply. 57.37. In the year 2006, what is the difference between the Balance of Payment (as % of service exports) of Georgia and Balance of Payment (as % of service exports) of Philippines?
Keep it short and to the point. 2.2. In the year 2006, what is the difference between the Balance of Payment (as % of service exports) of Georgia and Balance of Payment (as % of service exports) of Samoa?
Provide a short and direct response. -28.67. In the year 2006, what is the difference between the Balance of Payment (as % of service exports) in Georgia and Balance of Payment (as % of service exports) in South Africa?
Keep it short and to the point. -27.96. In the year 2006, what is the difference between the Balance of Payment (as % of service exports) of Philippines and Balance of Payment (as % of service exports) of Samoa?
Give a very brief answer. -30.87. In the year 2006, what is the difference between the Balance of Payment (as % of service exports) of Philippines and Balance of Payment (as % of service exports) of South Africa?
Provide a succinct answer. -30.16. In the year 2006, what is the difference between the Balance of Payment (as % of service exports) of Samoa and Balance of Payment (as % of service exports) of South Africa?
Keep it short and to the point. 0.71. In the year 2007, what is the difference between the Balance of Payment (as % of service exports) of Georgia and Balance of Payment (as % of service exports) of Philippines?
Your answer should be compact. -2.08. In the year 2007, what is the difference between the Balance of Payment (as % of service exports) in Georgia and Balance of Payment (as % of service exports) in Samoa?
Provide a succinct answer. -26.22. In the year 2007, what is the difference between the Balance of Payment (as % of service exports) of Georgia and Balance of Payment (as % of service exports) of South Africa?
Your response must be concise. -24.49. In the year 2007, what is the difference between the Balance of Payment (as % of service exports) in Philippines and Balance of Payment (as % of service exports) in Samoa?
Offer a terse response. -24.14. In the year 2007, what is the difference between the Balance of Payment (as % of service exports) of Philippines and Balance of Payment (as % of service exports) of South Africa?
Your answer should be very brief. -22.41. In the year 2007, what is the difference between the Balance of Payment (as % of service exports) in Samoa and Balance of Payment (as % of service exports) in South Africa?
Keep it short and to the point. 1.73. In the year 2008, what is the difference between the Balance of Payment (as % of service exports) of Georgia and Balance of Payment (as % of service exports) of Philippines?
Keep it short and to the point. 15.52. In the year 2008, what is the difference between the Balance of Payment (as % of service exports) of Georgia and Balance of Payment (as % of service exports) of Samoa?
Make the answer very short. -30.56. In the year 2008, what is the difference between the Balance of Payment (as % of service exports) in Georgia and Balance of Payment (as % of service exports) in South Africa?
Provide a short and direct response. -21.69. In the year 2008, what is the difference between the Balance of Payment (as % of service exports) in Philippines and Balance of Payment (as % of service exports) in Samoa?
Offer a terse response. -46.08. In the year 2008, what is the difference between the Balance of Payment (as % of service exports) of Philippines and Balance of Payment (as % of service exports) of South Africa?
Your response must be concise. -37.21. In the year 2008, what is the difference between the Balance of Payment (as % of service exports) in Samoa and Balance of Payment (as % of service exports) in South Africa?
Your response must be concise. 8.87. In the year 2009, what is the difference between the Balance of Payment (as % of service exports) in Georgia and Balance of Payment (as % of service exports) in Philippines?
Your response must be concise. 18.97. In the year 2009, what is the difference between the Balance of Payment (as % of service exports) in Georgia and Balance of Payment (as % of service exports) in Samoa?
Keep it short and to the point. -35.47. In the year 2009, what is the difference between the Balance of Payment (as % of service exports) in Georgia and Balance of Payment (as % of service exports) in South Africa?
Your answer should be very brief. -21.96. In the year 2009, what is the difference between the Balance of Payment (as % of service exports) in Philippines and Balance of Payment (as % of service exports) in Samoa?
Provide a succinct answer. -54.44. In the year 2009, what is the difference between the Balance of Payment (as % of service exports) in Philippines and Balance of Payment (as % of service exports) in South Africa?
Provide a short and direct response. -40.93. In the year 2009, what is the difference between the Balance of Payment (as % of service exports) of Samoa and Balance of Payment (as % of service exports) of South Africa?
Provide a succinct answer. 13.51. In the year 2010, what is the difference between the Balance of Payment (as % of service exports) in Georgia and Balance of Payment (as % of service exports) in Philippines?
Keep it short and to the point. 25.3. In the year 2010, what is the difference between the Balance of Payment (as % of service exports) of Georgia and Balance of Payment (as % of service exports) of Samoa?
Offer a very short reply. -27.87. In the year 2010, what is the difference between the Balance of Payment (as % of service exports) of Georgia and Balance of Payment (as % of service exports) of South Africa?
Ensure brevity in your answer.  -16.38. In the year 2010, what is the difference between the Balance of Payment (as % of service exports) in Philippines and Balance of Payment (as % of service exports) in Samoa?
Your response must be concise. -53.17. In the year 2010, what is the difference between the Balance of Payment (as % of service exports) of Philippines and Balance of Payment (as % of service exports) of South Africa?
Offer a terse response. -41.68. In the year 2010, what is the difference between the Balance of Payment (as % of service exports) of Samoa and Balance of Payment (as % of service exports) of South Africa?
Provide a short and direct response. 11.49. In the year 2011, what is the difference between the Balance of Payment (as % of service exports) of Georgia and Balance of Payment (as % of service exports) of Philippines?
Your response must be concise. 30.36. In the year 2011, what is the difference between the Balance of Payment (as % of service exports) of Georgia and Balance of Payment (as % of service exports) of Samoa?
Give a very brief answer. -24.37. In the year 2011, what is the difference between the Balance of Payment (as % of service exports) of Georgia and Balance of Payment (as % of service exports) of South Africa?
Offer a very short reply. -7.55. In the year 2011, what is the difference between the Balance of Payment (as % of service exports) of Philippines and Balance of Payment (as % of service exports) of Samoa?
Your answer should be compact. -54.73. In the year 2011, what is the difference between the Balance of Payment (as % of service exports) of Philippines and Balance of Payment (as % of service exports) of South Africa?
Make the answer very short. -37.91. In the year 2011, what is the difference between the Balance of Payment (as % of service exports) in Samoa and Balance of Payment (as % of service exports) in South Africa?
Your answer should be very brief. 16.82. In the year 2012, what is the difference between the Balance of Payment (as % of service exports) in Georgia and Balance of Payment (as % of service exports) in Philippines?
Your answer should be very brief. 35.2. In the year 2012, what is the difference between the Balance of Payment (as % of service exports) in Georgia and Balance of Payment (as % of service exports) in Samoa?
Offer a very short reply. -14.85. In the year 2012, what is the difference between the Balance of Payment (as % of service exports) of Georgia and Balance of Payment (as % of service exports) of South Africa?
Make the answer very short. -1.6. In the year 2012, what is the difference between the Balance of Payment (as % of service exports) in Philippines and Balance of Payment (as % of service exports) in Samoa?
Provide a succinct answer. -50.06. In the year 2012, what is the difference between the Balance of Payment (as % of service exports) in Philippines and Balance of Payment (as % of service exports) in South Africa?
Offer a very short reply. -36.8. In the year 2012, what is the difference between the Balance of Payment (as % of service exports) in Samoa and Balance of Payment (as % of service exports) in South Africa?
Offer a very short reply. 13.26. In the year 2013, what is the difference between the Balance of Payment (as % of service exports) of Georgia and Balance of Payment (as % of service exports) of Philippines?
Ensure brevity in your answer.  37.54. In the year 2013, what is the difference between the Balance of Payment (as % of service exports) in Georgia and Balance of Payment (as % of service exports) in Samoa?
Provide a short and direct response. -9.94. In the year 2013, what is the difference between the Balance of Payment (as % of service exports) in Georgia and Balance of Payment (as % of service exports) in South Africa?
Provide a succinct answer. 2.66. In the year 2013, what is the difference between the Balance of Payment (as % of service exports) of Philippines and Balance of Payment (as % of service exports) of Samoa?
Keep it short and to the point. -47.48. In the year 2013, what is the difference between the Balance of Payment (as % of service exports) in Philippines and Balance of Payment (as % of service exports) in South Africa?
Keep it short and to the point. -34.88. In the year 2013, what is the difference between the Balance of Payment (as % of service exports) of Samoa and Balance of Payment (as % of service exports) of South Africa?
Give a very brief answer. 12.6. What is the ratio of the Balance of Payment (as % of service exports) in Georgia in 2006 to that in 2007?
Keep it short and to the point. 0.99. What is the ratio of the Balance of Payment (as % of service exports) of Philippines in 2006 to that in 2007?
Give a very brief answer. 0.87. What is the ratio of the Balance of Payment (as % of service exports) in Samoa in 2006 to that in 2007?
Make the answer very short. 1.03. What is the ratio of the Balance of Payment (as % of service exports) in South Africa in 2006 to that in 2007?
Make the answer very short. 1.05. What is the ratio of the Balance of Payment (as % of service exports) in Georgia in 2006 to that in 2008?
Provide a short and direct response. 0.97. What is the ratio of the Balance of Payment (as % of service exports) of Philippines in 2006 to that in 2008?
Provide a succinct answer. 1.63. What is the ratio of the Balance of Payment (as % of service exports) of Samoa in 2006 to that in 2008?
Offer a very short reply. 0.96. What is the ratio of the Balance of Payment (as % of service exports) in South Africa in 2006 to that in 2008?
Your answer should be very brief. 1.09. What is the ratio of the Balance of Payment (as % of service exports) of Georgia in 2006 to that in 2009?
Make the answer very short. 0.96. What is the ratio of the Balance of Payment (as % of service exports) in Philippines in 2006 to that in 2009?
Provide a succinct answer. 1.9. What is the ratio of the Balance of Payment (as % of service exports) of Samoa in 2006 to that in 2009?
Offer a terse response. 0.88. What is the ratio of the Balance of Payment (as % of service exports) of South Africa in 2006 to that in 2009?
Your response must be concise. 1.08. What is the ratio of the Balance of Payment (as % of service exports) in Georgia in 2006 to that in 2010?
Your response must be concise. 0.85. What is the ratio of the Balance of Payment (as % of service exports) in Philippines in 2006 to that in 2010?
Make the answer very short. 2.15. What is the ratio of the Balance of Payment (as % of service exports) in Samoa in 2006 to that in 2010?
Make the answer very short. 0.92. What is the ratio of the Balance of Payment (as % of service exports) of South Africa in 2006 to that in 2010?
Make the answer very short. 1.1. What is the ratio of the Balance of Payment (as % of service exports) of Georgia in 2006 to that in 2011?
Provide a short and direct response. 0.72. What is the ratio of the Balance of Payment (as % of service exports) of Philippines in 2006 to that in 2011?
Give a very brief answer. 1.89. What is the ratio of the Balance of Payment (as % of service exports) in Samoa in 2006 to that in 2011?
Offer a terse response. 0.88. What is the ratio of the Balance of Payment (as % of service exports) in South Africa in 2006 to that in 2011?
Keep it short and to the point. 1.13. What is the ratio of the Balance of Payment (as % of service exports) in Georgia in 2006 to that in 2012?
Give a very brief answer. 0.62. What is the ratio of the Balance of Payment (as % of service exports) in Philippines in 2006 to that in 2012?
Keep it short and to the point. 1.61. What is the ratio of the Balance of Payment (as % of service exports) of Samoa in 2006 to that in 2012?
Provide a succinct answer. 0.9. What is the ratio of the Balance of Payment (as % of service exports) in South Africa in 2006 to that in 2012?
Your response must be concise. 1.1. What is the ratio of the Balance of Payment (as % of service exports) of Georgia in 2006 to that in 2013?
Provide a short and direct response. 0.59. What is the ratio of the Balance of Payment (as % of service exports) in Philippines in 2006 to that in 2013?
Keep it short and to the point. 1.59. What is the ratio of the Balance of Payment (as % of service exports) of Samoa in 2006 to that in 2013?
Give a very brief answer. 0.93. What is the ratio of the Balance of Payment (as % of service exports) of South Africa in 2006 to that in 2013?
Your response must be concise. 1.13. What is the ratio of the Balance of Payment (as % of service exports) of Georgia in 2007 to that in 2008?
Give a very brief answer. 0.99. What is the ratio of the Balance of Payment (as % of service exports) of Philippines in 2007 to that in 2008?
Offer a very short reply. 1.87. What is the ratio of the Balance of Payment (as % of service exports) in Samoa in 2007 to that in 2008?
Make the answer very short. 0.93. What is the ratio of the Balance of Payment (as % of service exports) of South Africa in 2007 to that in 2008?
Keep it short and to the point. 1.04. What is the ratio of the Balance of Payment (as % of service exports) in Georgia in 2007 to that in 2009?
Ensure brevity in your answer.  0.97. What is the ratio of the Balance of Payment (as % of service exports) of Philippines in 2007 to that in 2009?
Ensure brevity in your answer.  2.18. What is the ratio of the Balance of Payment (as % of service exports) in Samoa in 2007 to that in 2009?
Give a very brief answer. 0.85. What is the ratio of the Balance of Payment (as % of service exports) in South Africa in 2007 to that in 2009?
Your response must be concise. 1.02. What is the ratio of the Balance of Payment (as % of service exports) in Georgia in 2007 to that in 2010?
Offer a terse response. 0.86. What is the ratio of the Balance of Payment (as % of service exports) of Philippines in 2007 to that in 2010?
Offer a very short reply. 2.47. What is the ratio of the Balance of Payment (as % of service exports) in Samoa in 2007 to that in 2010?
Keep it short and to the point. 0.89. What is the ratio of the Balance of Payment (as % of service exports) of South Africa in 2007 to that in 2010?
Ensure brevity in your answer.  1.05. What is the ratio of the Balance of Payment (as % of service exports) of Georgia in 2007 to that in 2011?
Ensure brevity in your answer.  0.73. What is the ratio of the Balance of Payment (as % of service exports) in Philippines in 2007 to that in 2011?
Your response must be concise. 2.17. What is the ratio of the Balance of Payment (as % of service exports) of Samoa in 2007 to that in 2011?
Your answer should be very brief. 0.85. What is the ratio of the Balance of Payment (as % of service exports) of South Africa in 2007 to that in 2011?
Make the answer very short. 1.08. What is the ratio of the Balance of Payment (as % of service exports) in Georgia in 2007 to that in 2012?
Provide a succinct answer. 0.63. What is the ratio of the Balance of Payment (as % of service exports) in Philippines in 2007 to that in 2012?
Ensure brevity in your answer.  1.85. What is the ratio of the Balance of Payment (as % of service exports) of Samoa in 2007 to that in 2012?
Offer a terse response. 0.87. What is the ratio of the Balance of Payment (as % of service exports) of South Africa in 2007 to that in 2012?
Keep it short and to the point. 1.04. What is the ratio of the Balance of Payment (as % of service exports) in Georgia in 2007 to that in 2013?
Provide a short and direct response. 0.6. What is the ratio of the Balance of Payment (as % of service exports) in Philippines in 2007 to that in 2013?
Ensure brevity in your answer.  1.83. What is the ratio of the Balance of Payment (as % of service exports) in Samoa in 2007 to that in 2013?
Keep it short and to the point. 0.9. What is the ratio of the Balance of Payment (as % of service exports) in South Africa in 2007 to that in 2013?
Your response must be concise. 1.08. What is the ratio of the Balance of Payment (as % of service exports) of Georgia in 2008 to that in 2009?
Keep it short and to the point. 0.98. What is the ratio of the Balance of Payment (as % of service exports) of Philippines in 2008 to that in 2009?
Offer a very short reply. 1.17. What is the ratio of the Balance of Payment (as % of service exports) in Samoa in 2008 to that in 2009?
Make the answer very short. 0.92. What is the ratio of the Balance of Payment (as % of service exports) in South Africa in 2008 to that in 2009?
Your answer should be compact. 0.98. What is the ratio of the Balance of Payment (as % of service exports) of Georgia in 2008 to that in 2010?
Make the answer very short. 0.87. What is the ratio of the Balance of Payment (as % of service exports) in Philippines in 2008 to that in 2010?
Offer a very short reply. 1.32. What is the ratio of the Balance of Payment (as % of service exports) in Samoa in 2008 to that in 2010?
Your answer should be very brief. 0.97. What is the ratio of the Balance of Payment (as % of service exports) of South Africa in 2008 to that in 2010?
Give a very brief answer. 1. What is the ratio of the Balance of Payment (as % of service exports) of Georgia in 2008 to that in 2011?
Provide a short and direct response. 0.74. What is the ratio of the Balance of Payment (as % of service exports) in Philippines in 2008 to that in 2011?
Offer a very short reply. 1.16. What is the ratio of the Balance of Payment (as % of service exports) in Samoa in 2008 to that in 2011?
Make the answer very short. 0.92. What is the ratio of the Balance of Payment (as % of service exports) in South Africa in 2008 to that in 2011?
Offer a terse response. 1.04. What is the ratio of the Balance of Payment (as % of service exports) in Georgia in 2008 to that in 2012?
Provide a succinct answer. 0.64. What is the ratio of the Balance of Payment (as % of service exports) of Philippines in 2008 to that in 2012?
Your answer should be compact. 0.99. What is the ratio of the Balance of Payment (as % of service exports) in Samoa in 2008 to that in 2012?
Keep it short and to the point. 0.94. What is the ratio of the Balance of Payment (as % of service exports) in Georgia in 2008 to that in 2013?
Make the answer very short. 0.61. What is the ratio of the Balance of Payment (as % of service exports) in Philippines in 2008 to that in 2013?
Your answer should be very brief. 0.98. What is the ratio of the Balance of Payment (as % of service exports) of Samoa in 2008 to that in 2013?
Give a very brief answer. 0.97. What is the ratio of the Balance of Payment (as % of service exports) of South Africa in 2008 to that in 2013?
Keep it short and to the point. 1.03. What is the ratio of the Balance of Payment (as % of service exports) of Georgia in 2009 to that in 2010?
Make the answer very short. 0.89. What is the ratio of the Balance of Payment (as % of service exports) of Philippines in 2009 to that in 2010?
Give a very brief answer. 1.13. What is the ratio of the Balance of Payment (as % of service exports) in Samoa in 2009 to that in 2010?
Keep it short and to the point. 1.05. What is the ratio of the Balance of Payment (as % of service exports) in South Africa in 2009 to that in 2010?
Keep it short and to the point. 1.02. What is the ratio of the Balance of Payment (as % of service exports) of Georgia in 2009 to that in 2011?
Give a very brief answer. 0.76. What is the ratio of the Balance of Payment (as % of service exports) of Philippines in 2009 to that in 2011?
Keep it short and to the point. 0.99. What is the ratio of the Balance of Payment (as % of service exports) of South Africa in 2009 to that in 2011?
Provide a short and direct response. 1.05. What is the ratio of the Balance of Payment (as % of service exports) of Georgia in 2009 to that in 2012?
Make the answer very short. 0.65. What is the ratio of the Balance of Payment (as % of service exports) of Philippines in 2009 to that in 2012?
Offer a terse response. 0.85. What is the ratio of the Balance of Payment (as % of service exports) in Samoa in 2009 to that in 2012?
Your answer should be compact. 1.02. What is the ratio of the Balance of Payment (as % of service exports) in South Africa in 2009 to that in 2012?
Provide a succinct answer. 1.02. What is the ratio of the Balance of Payment (as % of service exports) of Georgia in 2009 to that in 2013?
Offer a terse response. 0.62. What is the ratio of the Balance of Payment (as % of service exports) of Philippines in 2009 to that in 2013?
Provide a short and direct response. 0.84. What is the ratio of the Balance of Payment (as % of service exports) in Samoa in 2009 to that in 2013?
Offer a very short reply. 1.05. What is the ratio of the Balance of Payment (as % of service exports) in South Africa in 2009 to that in 2013?
Make the answer very short. 1.05. What is the ratio of the Balance of Payment (as % of service exports) of Georgia in 2010 to that in 2011?
Offer a very short reply. 0.85. What is the ratio of the Balance of Payment (as % of service exports) of Philippines in 2010 to that in 2011?
Offer a terse response. 0.88. What is the ratio of the Balance of Payment (as % of service exports) in Samoa in 2010 to that in 2011?
Provide a short and direct response. 0.95. What is the ratio of the Balance of Payment (as % of service exports) of South Africa in 2010 to that in 2011?
Ensure brevity in your answer.  1.03. What is the ratio of the Balance of Payment (as % of service exports) of Georgia in 2010 to that in 2012?
Offer a very short reply. 0.73. What is the ratio of the Balance of Payment (as % of service exports) of Philippines in 2010 to that in 2012?
Ensure brevity in your answer.  0.75. What is the ratio of the Balance of Payment (as % of service exports) in Samoa in 2010 to that in 2012?
Your response must be concise. 0.97. What is the ratio of the Balance of Payment (as % of service exports) in South Africa in 2010 to that in 2012?
Provide a short and direct response. 1. What is the ratio of the Balance of Payment (as % of service exports) of Georgia in 2010 to that in 2013?
Your answer should be very brief. 0.7. What is the ratio of the Balance of Payment (as % of service exports) of Philippines in 2010 to that in 2013?
Offer a very short reply. 0.74. What is the ratio of the Balance of Payment (as % of service exports) of Samoa in 2010 to that in 2013?
Give a very brief answer. 1.01. What is the ratio of the Balance of Payment (as % of service exports) in South Africa in 2010 to that in 2013?
Your answer should be compact. 1.03. What is the ratio of the Balance of Payment (as % of service exports) of Georgia in 2011 to that in 2012?
Provide a short and direct response. 0.86. What is the ratio of the Balance of Payment (as % of service exports) of Philippines in 2011 to that in 2012?
Offer a very short reply. 0.85. What is the ratio of the Balance of Payment (as % of service exports) of Samoa in 2011 to that in 2012?
Ensure brevity in your answer.  1.02. What is the ratio of the Balance of Payment (as % of service exports) of South Africa in 2011 to that in 2012?
Provide a short and direct response. 0.97. What is the ratio of the Balance of Payment (as % of service exports) of Georgia in 2011 to that in 2013?
Make the answer very short. 0.82. What is the ratio of the Balance of Payment (as % of service exports) of Philippines in 2011 to that in 2013?
Offer a terse response. 0.84. What is the ratio of the Balance of Payment (as % of service exports) of Samoa in 2011 to that in 2013?
Your answer should be very brief. 1.06. What is the ratio of the Balance of Payment (as % of service exports) of Georgia in 2012 to that in 2013?
Your response must be concise. 0.96. What is the ratio of the Balance of Payment (as % of service exports) in Philippines in 2012 to that in 2013?
Provide a succinct answer. 0.99. What is the ratio of the Balance of Payment (as % of service exports) in Samoa in 2012 to that in 2013?
Give a very brief answer. 1.03. What is the ratio of the Balance of Payment (as % of service exports) in South Africa in 2012 to that in 2013?
Make the answer very short. 1.03. What is the difference between the highest and the second highest Balance of Payment (as % of service exports) in Georgia?
Provide a succinct answer. 2.56. What is the difference between the highest and the second highest Balance of Payment (as % of service exports) of Philippines?
Provide a short and direct response. 4.73. What is the difference between the highest and the second highest Balance of Payment (as % of service exports) in Samoa?
Offer a terse response. 0.4. What is the difference between the highest and the second highest Balance of Payment (as % of service exports) of South Africa?
Offer a very short reply. 3.02. What is the difference between the highest and the lowest Balance of Payment (as % of service exports) in Georgia?
Give a very brief answer. 23.42. What is the difference between the highest and the lowest Balance of Payment (as % of service exports) in Philippines?
Make the answer very short. 21.87. What is the difference between the highest and the lowest Balance of Payment (as % of service exports) in Samoa?
Your response must be concise. 10.79. What is the difference between the highest and the lowest Balance of Payment (as % of service exports) in South Africa?
Give a very brief answer. 7.32. 